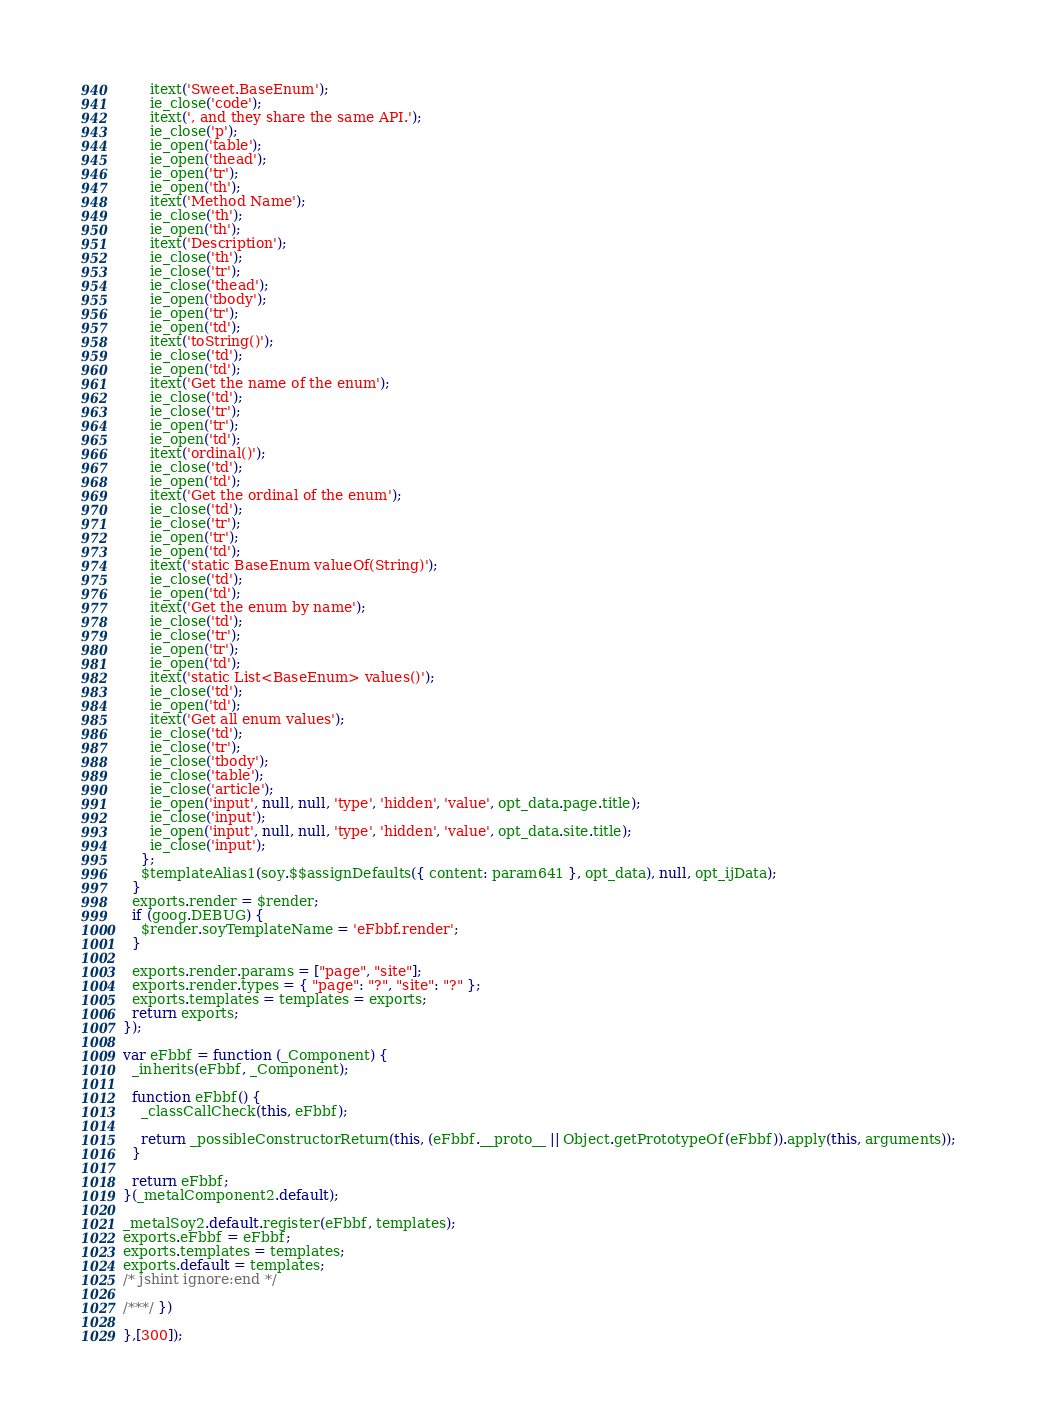Convert code to text. <code><loc_0><loc_0><loc_500><loc_500><_JavaScript_>      itext('Sweet.BaseEnum');
      ie_close('code');
      itext(', and they share the same API.');
      ie_close('p');
      ie_open('table');
      ie_open('thead');
      ie_open('tr');
      ie_open('th');
      itext('Method Name');
      ie_close('th');
      ie_open('th');
      itext('Description');
      ie_close('th');
      ie_close('tr');
      ie_close('thead');
      ie_open('tbody');
      ie_open('tr');
      ie_open('td');
      itext('toString()');
      ie_close('td');
      ie_open('td');
      itext('Get the name of the enum');
      ie_close('td');
      ie_close('tr');
      ie_open('tr');
      ie_open('td');
      itext('ordinal()');
      ie_close('td');
      ie_open('td');
      itext('Get the ordinal of the enum');
      ie_close('td');
      ie_close('tr');
      ie_open('tr');
      ie_open('td');
      itext('static BaseEnum valueOf(String)');
      ie_close('td');
      ie_open('td');
      itext('Get the enum by name');
      ie_close('td');
      ie_close('tr');
      ie_open('tr');
      ie_open('td');
      itext('static List<BaseEnum> values()');
      ie_close('td');
      ie_open('td');
      itext('Get all enum values');
      ie_close('td');
      ie_close('tr');
      ie_close('tbody');
      ie_close('table');
      ie_close('article');
      ie_open('input', null, null, 'type', 'hidden', 'value', opt_data.page.title);
      ie_close('input');
      ie_open('input', null, null, 'type', 'hidden', 'value', opt_data.site.title);
      ie_close('input');
    };
    $templateAlias1(soy.$$assignDefaults({ content: param641 }, opt_data), null, opt_ijData);
  }
  exports.render = $render;
  if (goog.DEBUG) {
    $render.soyTemplateName = 'eFbbf.render';
  }

  exports.render.params = ["page", "site"];
  exports.render.types = { "page": "?", "site": "?" };
  exports.templates = templates = exports;
  return exports;
});

var eFbbf = function (_Component) {
  _inherits(eFbbf, _Component);

  function eFbbf() {
    _classCallCheck(this, eFbbf);

    return _possibleConstructorReturn(this, (eFbbf.__proto__ || Object.getPrototypeOf(eFbbf)).apply(this, arguments));
  }

  return eFbbf;
}(_metalComponent2.default);

_metalSoy2.default.register(eFbbf, templates);
exports.eFbbf = eFbbf;
exports.templates = templates;
exports.default = templates;
/* jshint ignore:end */

/***/ })

},[300]);</code> 